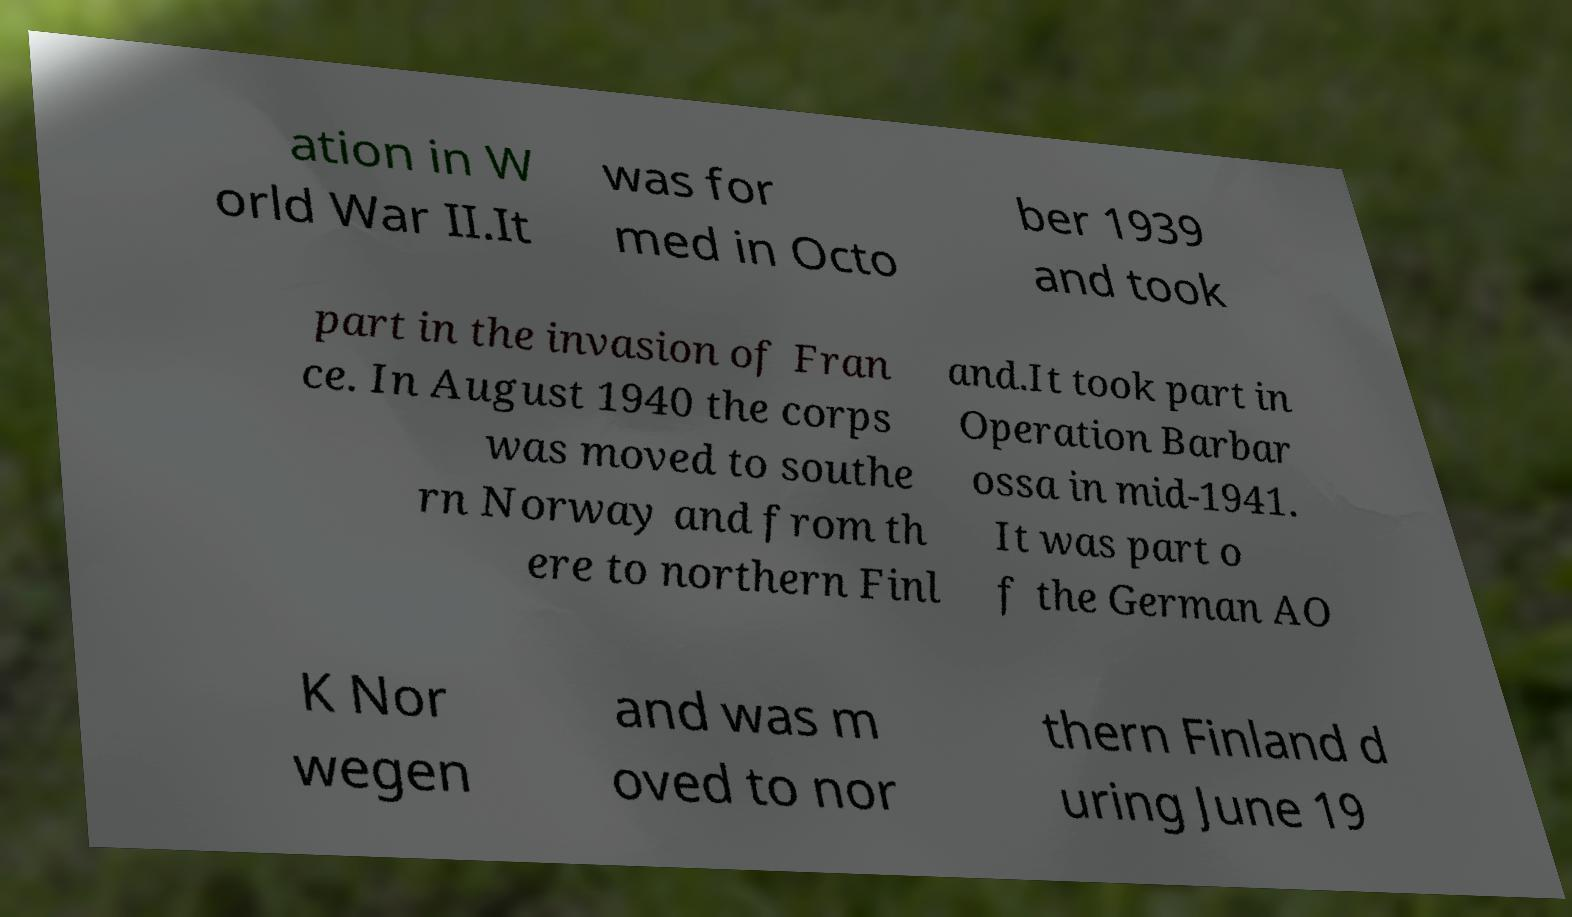There's text embedded in this image that I need extracted. Can you transcribe it verbatim? ation in W orld War II.It was for med in Octo ber 1939 and took part in the invasion of Fran ce. In August 1940 the corps was moved to southe rn Norway and from th ere to northern Finl and.It took part in Operation Barbar ossa in mid-1941. It was part o f the German AO K Nor wegen and was m oved to nor thern Finland d uring June 19 